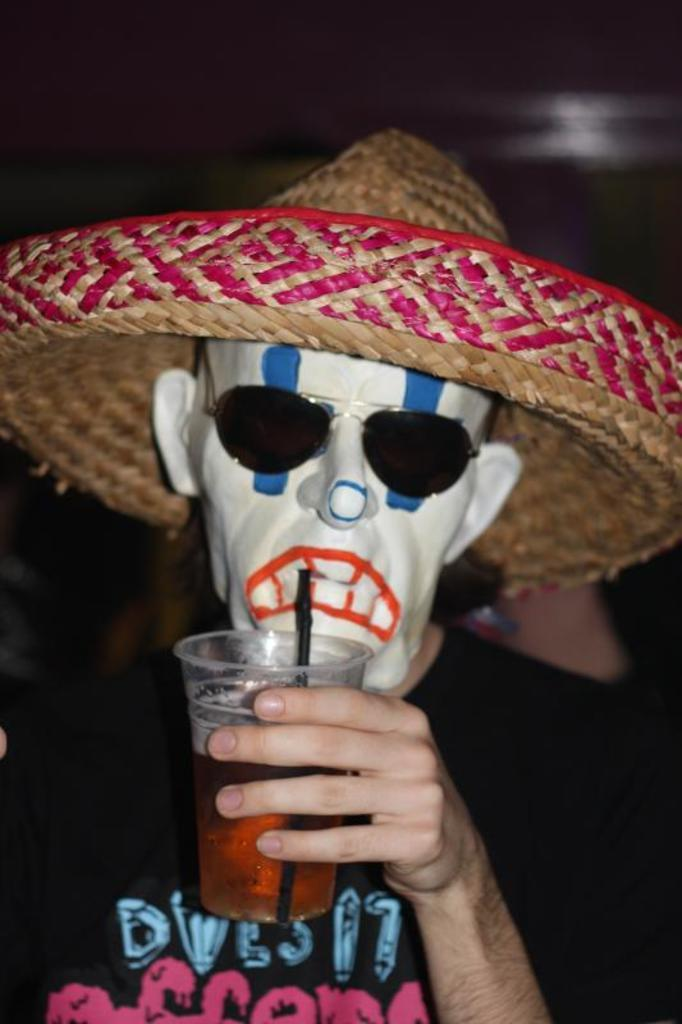What is the main subject of the image? There is a person in the image. What is the person wearing on their upper body? The person is wearing a black t-shirt. What type of headwear is the person wearing? The person is wearing a hat. What object is the person holding in the image? The person is holding a glass. How would you describe the lighting or color of the background in the image? The background of the image is dark. What type of wax can be seen dripping from the person's fang in the image? There is no wax or fang present in the image; the person is simply holding a glass. 